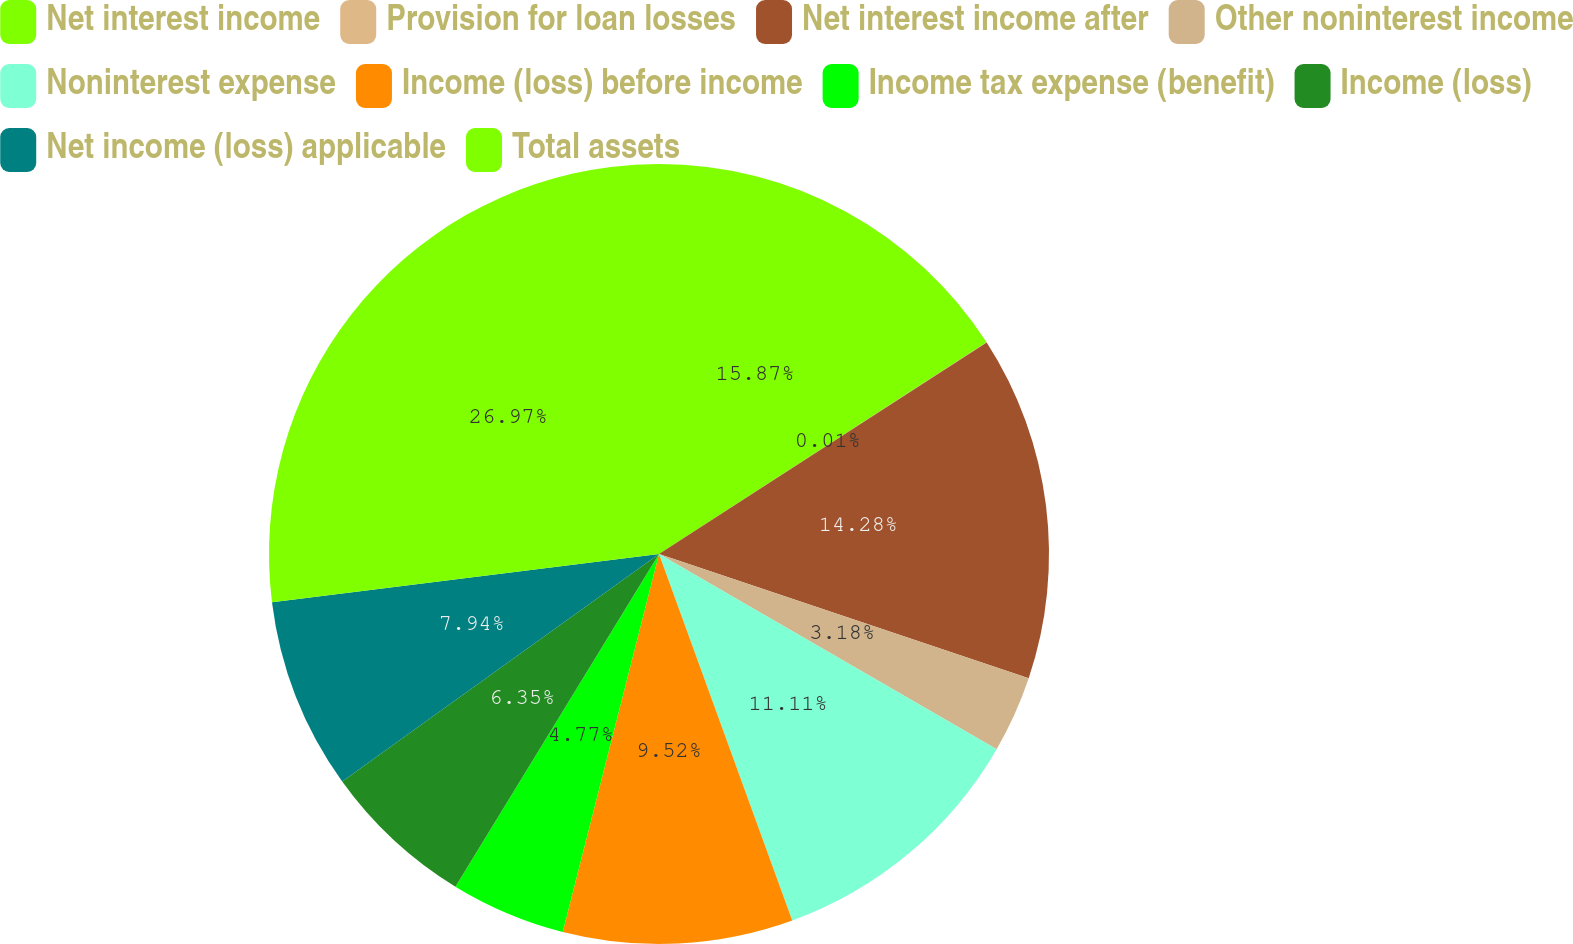Convert chart. <chart><loc_0><loc_0><loc_500><loc_500><pie_chart><fcel>Net interest income<fcel>Provision for loan losses<fcel>Net interest income after<fcel>Other noninterest income<fcel>Noninterest expense<fcel>Income (loss) before income<fcel>Income tax expense (benefit)<fcel>Income (loss)<fcel>Net income (loss) applicable<fcel>Total assets<nl><fcel>15.87%<fcel>0.01%<fcel>14.28%<fcel>3.18%<fcel>11.11%<fcel>9.52%<fcel>4.77%<fcel>6.35%<fcel>7.94%<fcel>26.97%<nl></chart> 